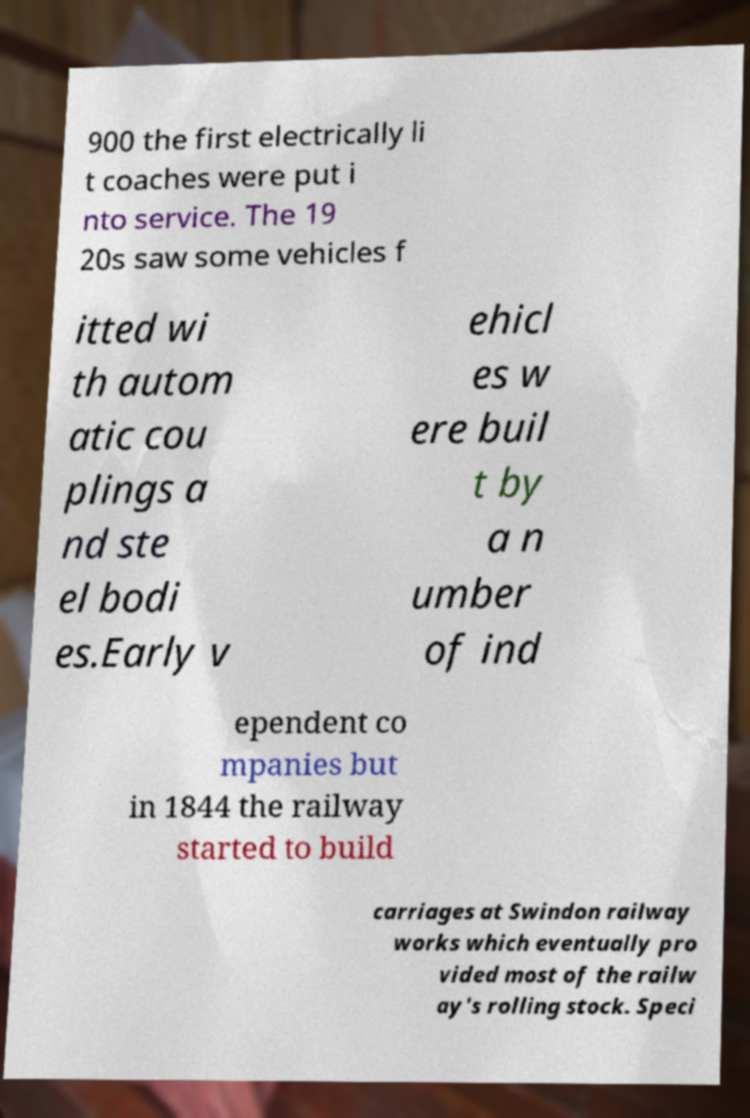Please identify and transcribe the text found in this image. 900 the first electrically li t coaches were put i nto service. The 19 20s saw some vehicles f itted wi th autom atic cou plings a nd ste el bodi es.Early v ehicl es w ere buil t by a n umber of ind ependent co mpanies but in 1844 the railway started to build carriages at Swindon railway works which eventually pro vided most of the railw ay's rolling stock. Speci 